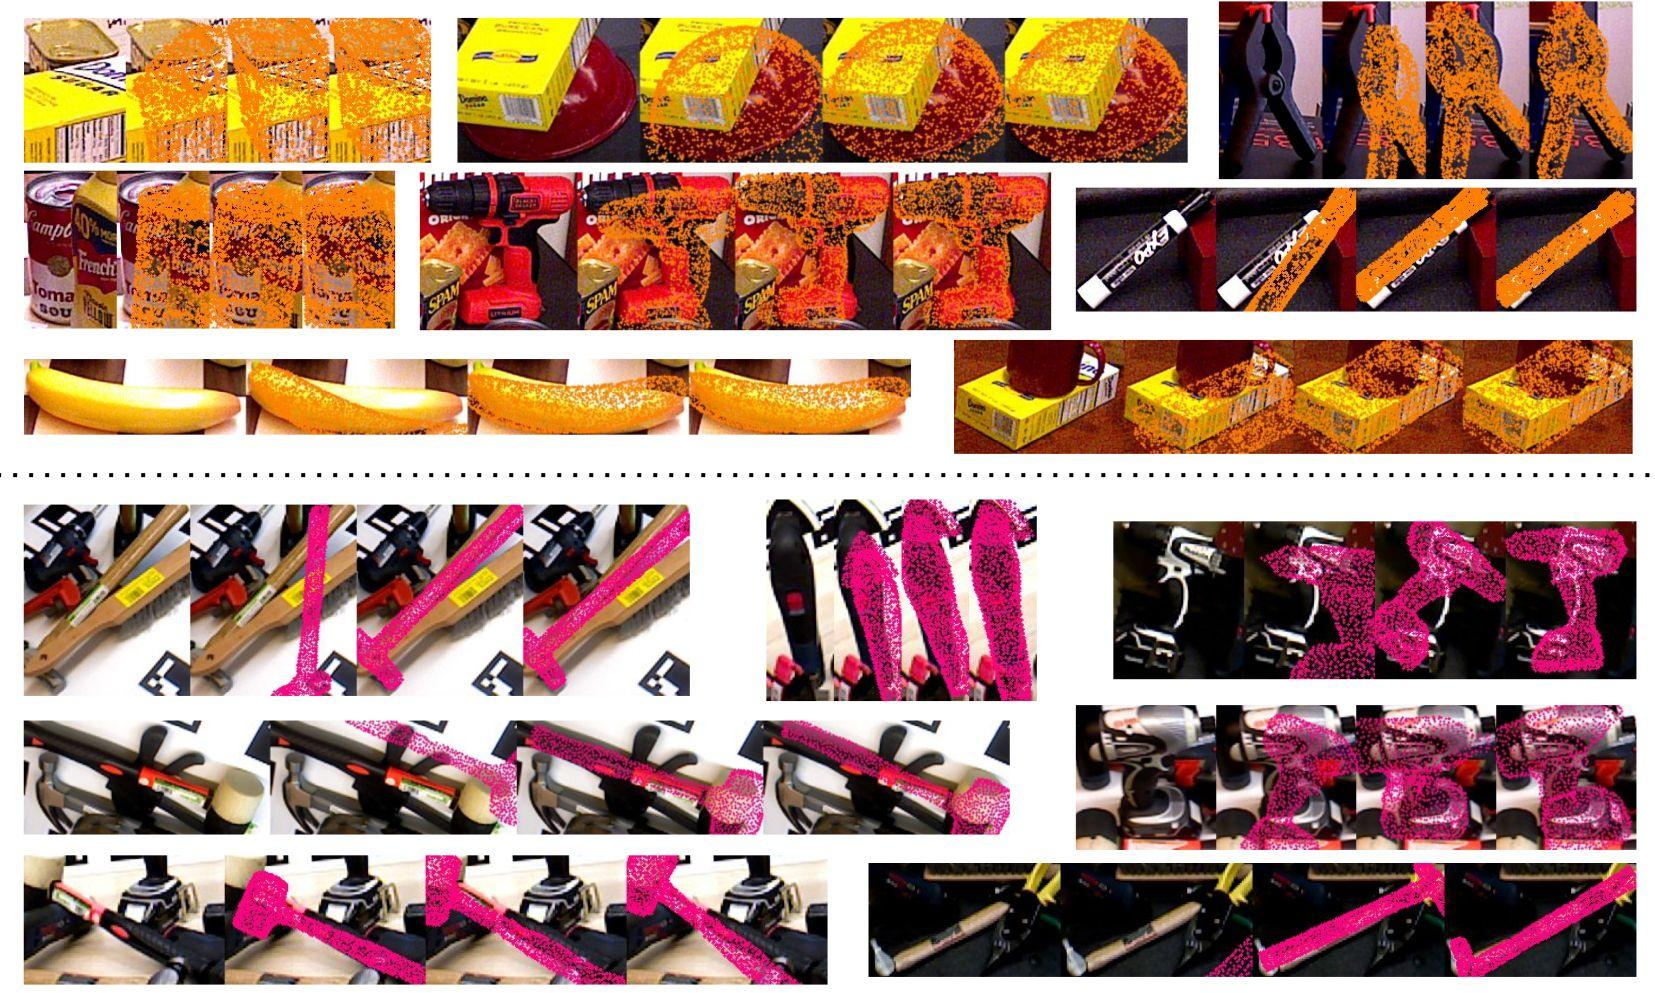Based on the disruption patterns observed, what is a common characteristic of the corruption applied across all rows? A) The corruption is applied more densely towards the center of the images. B) The corruption follows a horizontal strip pattern across the images. C) The disruption intensity is the same across all images. D) Each image within a row is corrupted with a different pattern. Upon close examination, the images display a distinctive corruption pattern characterized by horizontal stripes that progress across the visual field. These bands of disruption intensify from left to right, indicating a degradation in image clarity that simulates the effect of a corrupted digital file or a distorted analog signal. Think of it like static on an old television screen. This particular type of corruption provides a fascinating subject for study within the fields of digital image processing and error detection. To address the question directly, option B captures the essence of the images' corruption pattern most accurately – it's a horizontal strip pattern that intensifies from one image to the next, creating a sense of continuity and gradation across each row. 